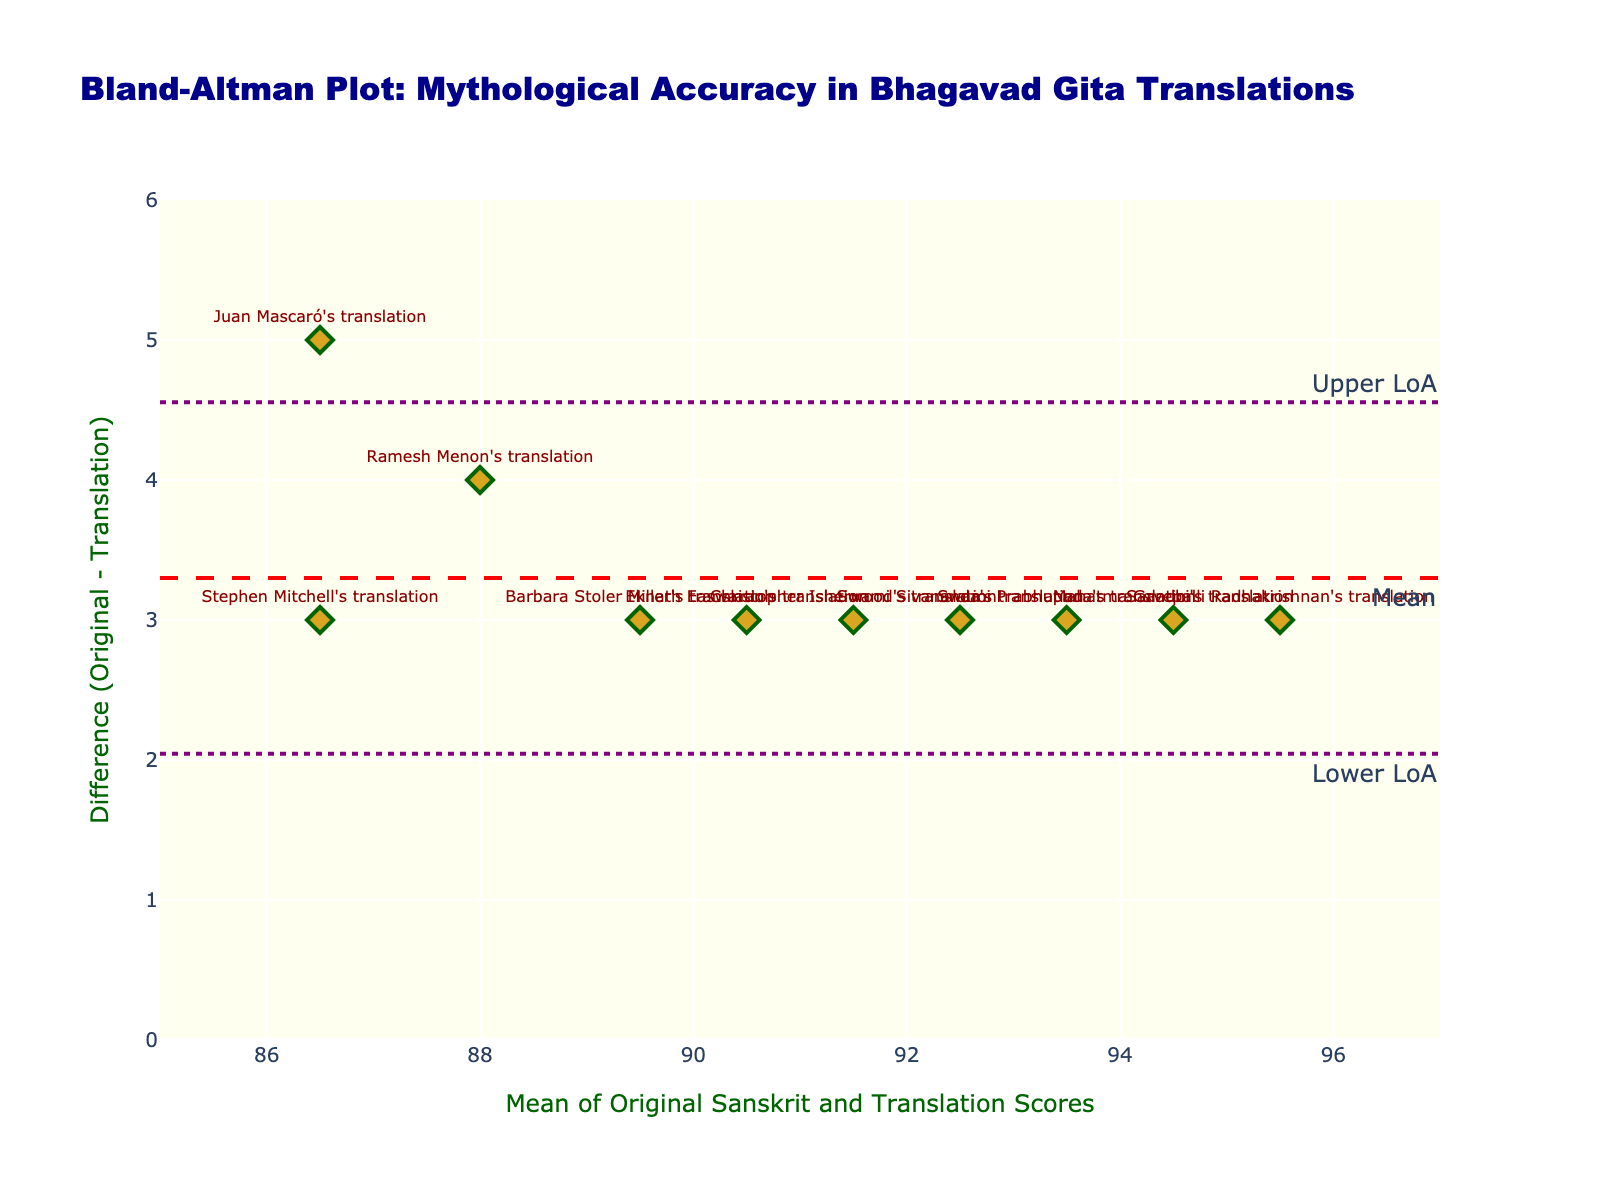What is the title of the plot? The title is located at the top center of the plot and often provides a summary of what the plot is about.
Answer: Bland-Altman Plot: Mythological Accuracy in Bhagavad Gita Translations How many translations are represented in the figure? Count the number of data points or textual labels in the figure. Each represents a different translation.
Answer: 10 What is the mean difference between the original Sanskrit score and the translation scores? The mean difference is typically indicated by a dashed line annotated with "Mean".
Answer: 3 Which translation has the highest mean score? Identify the data point with the highest value on the x-axis, which represents the mean score.
Answer: Sarvepalli Radhakrishnan's translation What are the upper and lower limits of agreement? Limits of agreement are usually marked by dotted lines; look for annotations such as "Upper LoA" and "Lower LoA".
Answer: Upper: 3.96, Lower: 2.04 What is the range of mean scores among all translations? The range is the difference between the maximum and minimum values of the mean scores.
Answer: 86.5 to 95.5 Which translation deviates the most from the original Sanskrit, and what is its difference? Look for the data point that is furthest from the mean difference line.
Answer: Juan Mascaró's translation, Difference: 5 For the translation with the lowest mean score, what is the difference value? Identify the point with the lowest x-axis value and read its y-axis value to find the difference.
Answer: Stephen Mitchell's translation, Difference: 3 What color are the markers representing the translations in the plot? Describe the visual appearance of the markers on the plot.
Answer: Goldenrod Are there any translations with a difference value below the lower limit of agreement? Compare each difference value (y-axis) against the lower limit of agreement line value.
Answer: No 